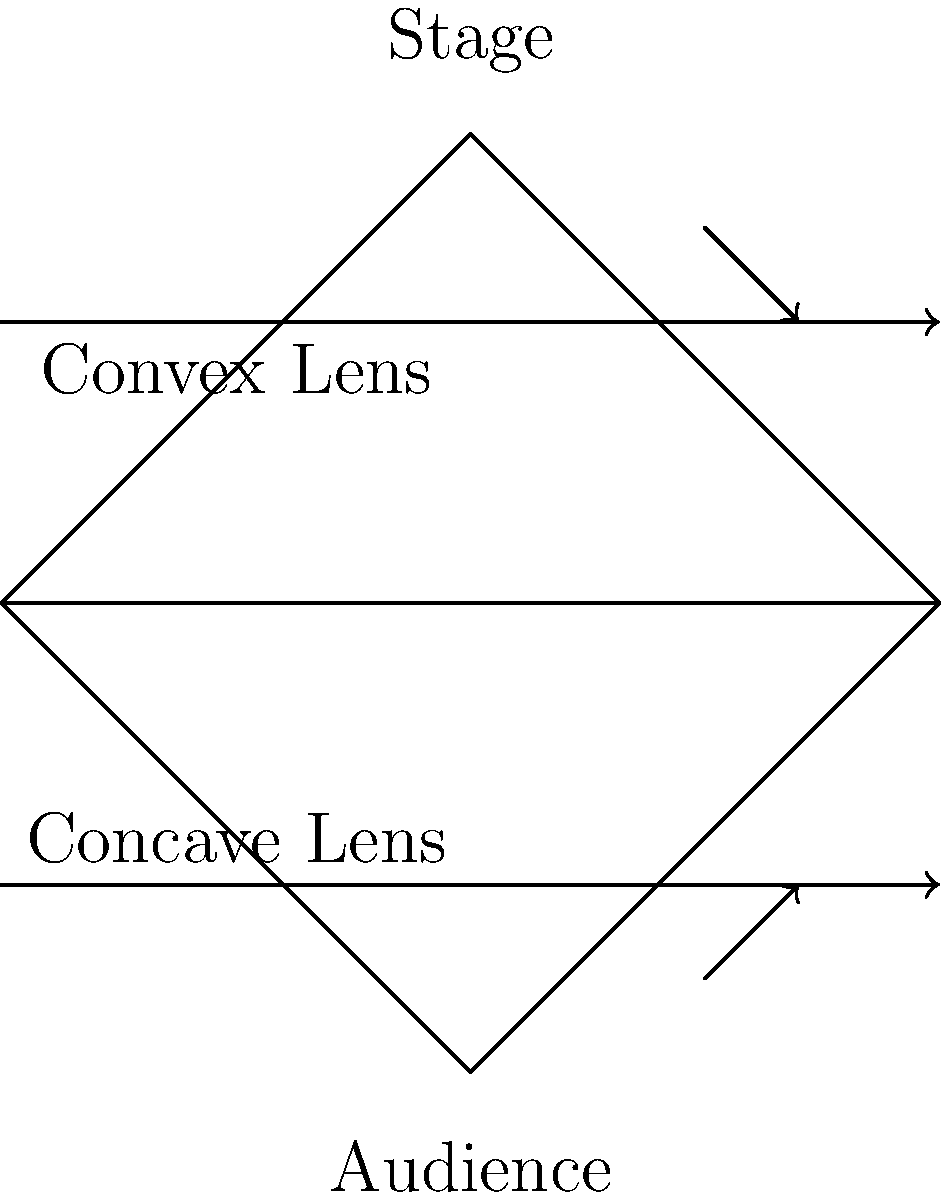At a Zac Brown Band concert, you notice the intricate stage lighting. The lighting technician uses a combination of convex and concave lenses to create different effects. If the band wants to create a focused spotlight on the lead singer, which type of lens should be used, and how does it affect the light rays? To understand which lens should be used for a focused spotlight, let's break down the properties of convex and concave lenses:

1. Convex lens:
   - Has a thicker center and thinner edges
   - Converges light rays
   - Creates a real, inverted image

2. Concave lens:
   - Has a thinner center and thicker edges
   - Diverges light rays
   - Creates a virtual, upright image

For a focused spotlight on the lead singer, we want to converge the light rays to create a concentrated beam of light. This is achieved using a convex lens.

The convex lens affects the light rays in the following way:
1. Parallel light rays enter the lens
2. As they pass through the lens, they bend towards the optical axis
3. The rays converge at a point called the focal point
4. Beyond the focal point, the light continues to travel in a focused beam

The focal length (f) of a convex lens is related to the radius of curvature (R) and the refractive index (n) of the lens material:

$$ \frac{1}{f} = (n-1)(\frac{1}{R_1} - \frac{1}{R_2}) $$

Where $R_1$ and $R_2$ are the radii of curvature of the two surfaces of the lens.

By adjusting the curvature and material of the convex lens, lighting technicians can control the focal length and create the desired spotlight effect for Zac Brown's performance.
Answer: Convex lens 